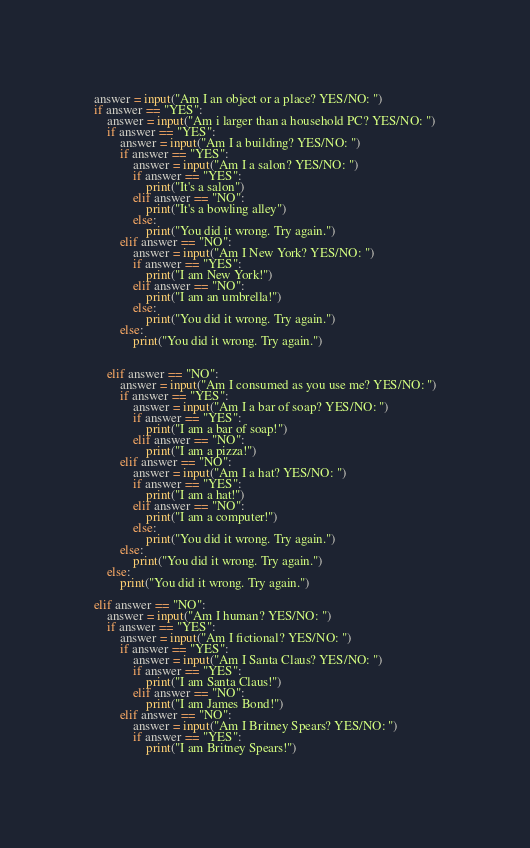Convert code to text. <code><loc_0><loc_0><loc_500><loc_500><_Python_>answer = input("Am I an object or a place? YES/NO: ")
if answer == "YES":
	answer = input("Am i larger than a household PC? YES/NO: ")
	if answer == "YES":
		answer = input("Am I a building? YES/NO: ")
		if answer == "YES":
			answer = input("Am I a salon? YES/NO: ")
			if answer == "YES":
				print("It's a salon")
			elif answer == "NO":
				print("It's a bowling alley")
			else:
				print("You did it wrong. Try again.")
		elif answer == "NO":
			answer = input("Am I New York? YES/NO: ")
			if answer == "YES":
				print("I am New York!")
			elif answer == "NO":
				print("I am an umbrella!")
			else:
				print("You did it wrong. Try again.")
		else:
			print("You did it wrong. Try again.")
		

	elif answer == "NO":
		answer = input("Am I consumed as you use me? YES/NO: ")
		if answer == "YES":
			answer = input("Am I a bar of soap? YES/NO: ")
			if answer == "YES":
				print("I am a bar of soap!")
			elif answer == "NO":
				print("I am a pizza!")
		elif answer == "NO":
			answer = input("Am I a hat? YES/NO: ")
			if answer == "YES":
				print("I am a hat!")
			elif answer == "NO":
				print("I am a computer!")
			else:
				print("You did it wrong. Try again.")
		else:
			print("You did it wrong. Try again.")
	else:
		print("You did it wrong. Try again.")

elif answer == "NO":
	answer = input("Am I human? YES/NO: ")
	if answer == "YES":
		answer = input("Am I fictional? YES/NO: ")
		if answer == "YES":
			answer = input("Am I Santa Claus? YES/NO: ")
			if answer == "YES":
				print("I am Santa Claus!")
			elif answer == "NO":
				print("I am James Bond!")
		elif answer == "NO":
			answer = input("Am I Britney Spears? YES/NO: ")
			if answer == "YES":
				print("I am Britney Spears!")</code> 